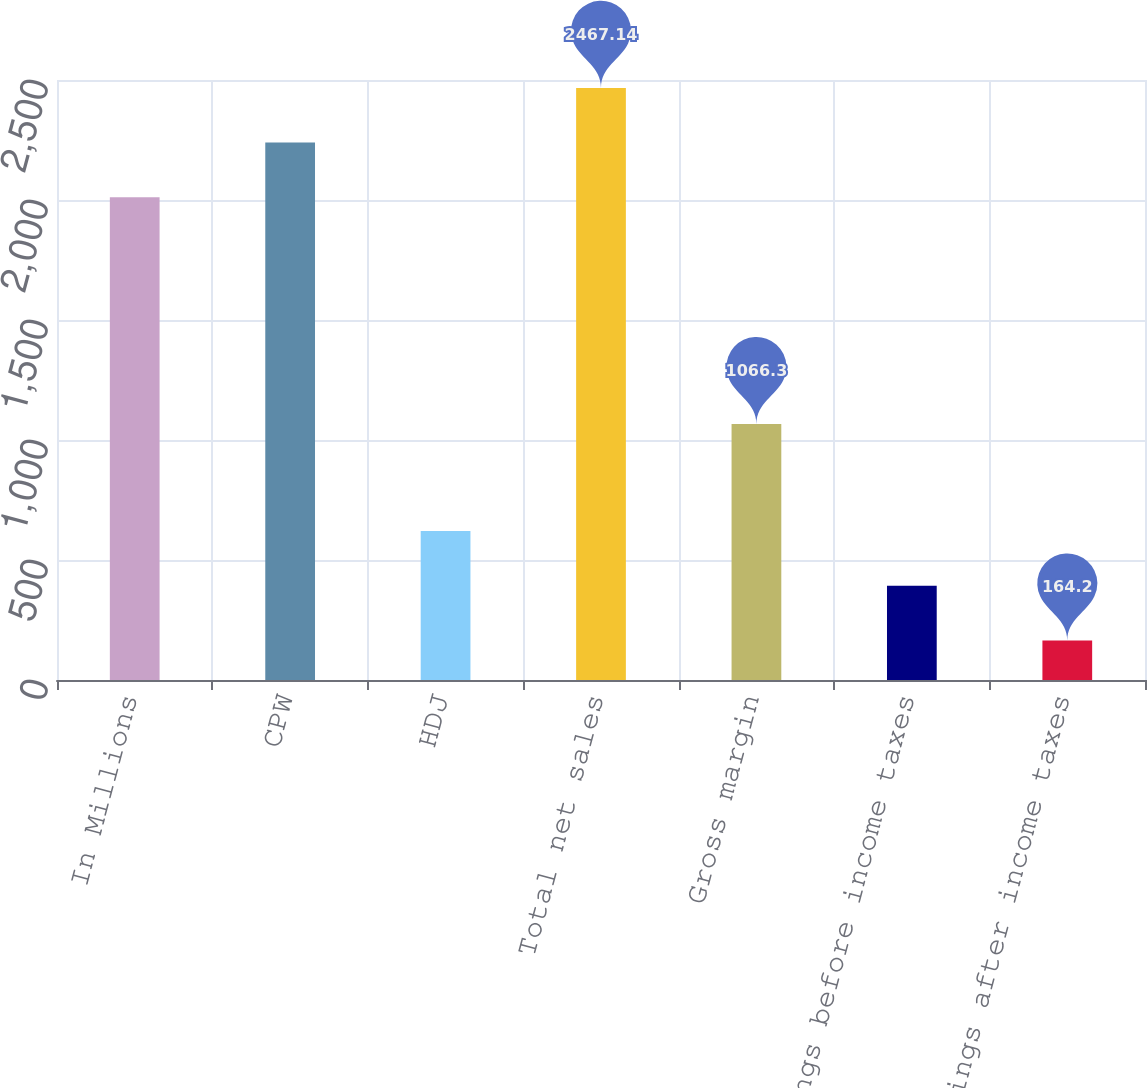Convert chart. <chart><loc_0><loc_0><loc_500><loc_500><bar_chart><fcel>In Millions<fcel>CPW<fcel>HDJ<fcel>Total net sales<fcel>Gross margin<fcel>Earnings before income taxes<fcel>Earnings after income taxes<nl><fcel>2011<fcel>2239.07<fcel>620.34<fcel>2467.14<fcel>1066.3<fcel>392.27<fcel>164.2<nl></chart> 